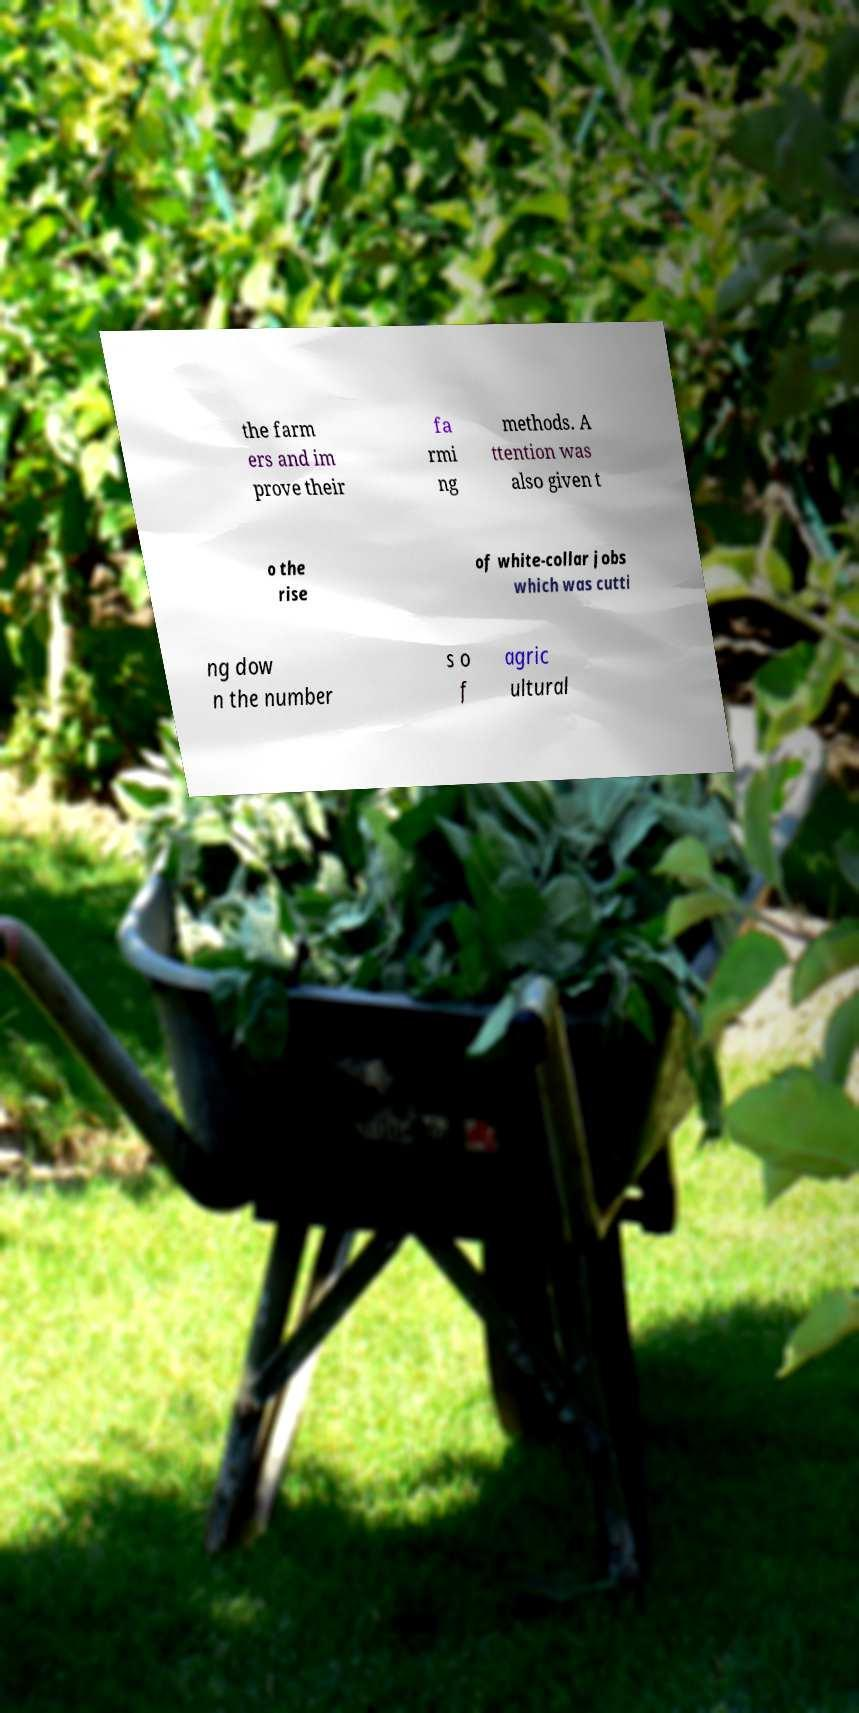Please identify and transcribe the text found in this image. the farm ers and im prove their fa rmi ng methods. A ttention was also given t o the rise of white-collar jobs which was cutti ng dow n the number s o f agric ultural 